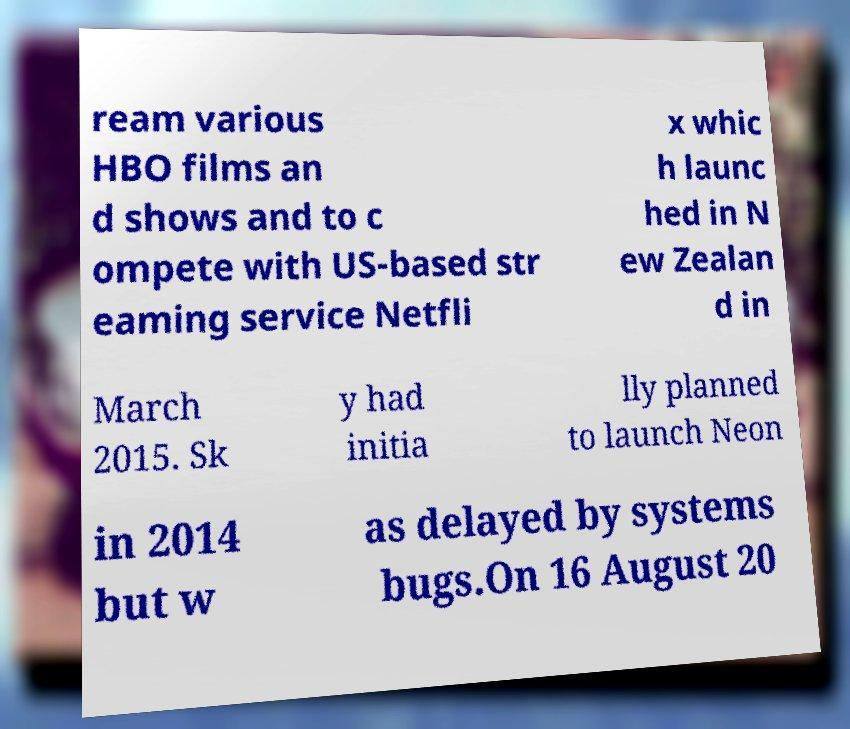Please identify and transcribe the text found in this image. ream various HBO films an d shows and to c ompete with US-based str eaming service Netfli x whic h launc hed in N ew Zealan d in March 2015. Sk y had initia lly planned to launch Neon in 2014 but w as delayed by systems bugs.On 16 August 20 